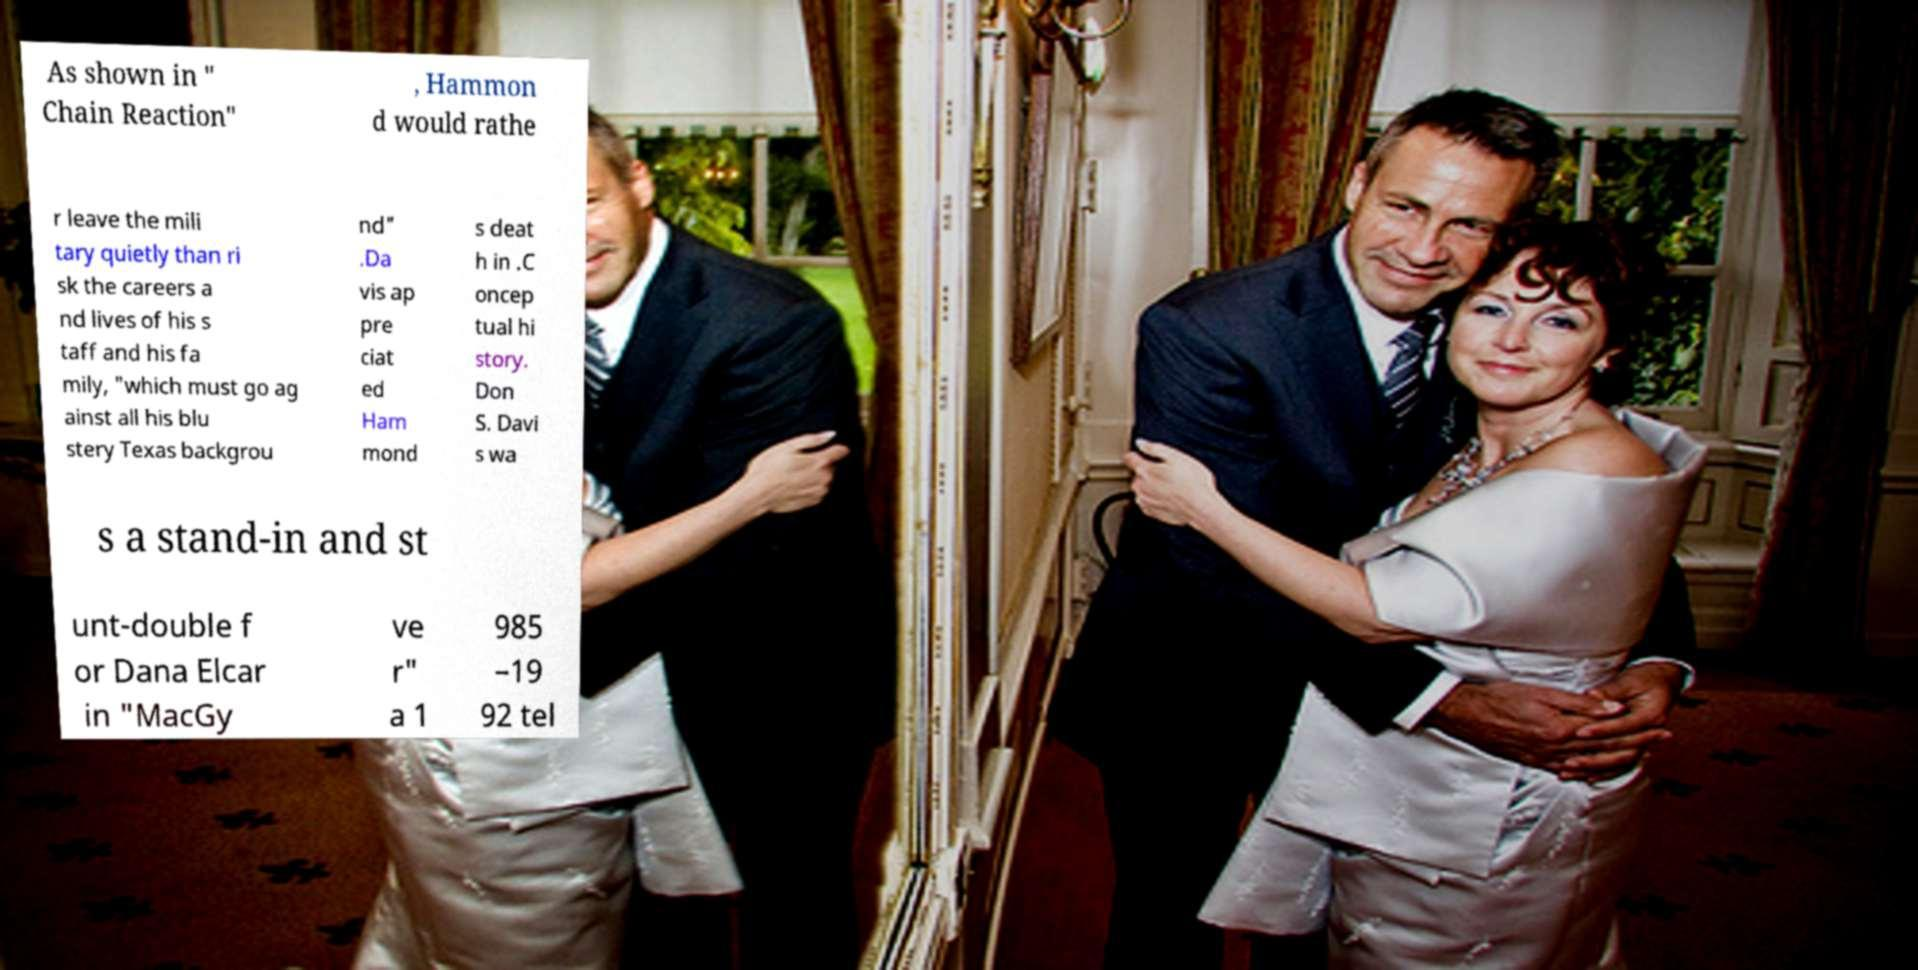Can you read and provide the text displayed in the image?This photo seems to have some interesting text. Can you extract and type it out for me? As shown in " Chain Reaction" , Hammon d would rathe r leave the mili tary quietly than ri sk the careers a nd lives of his s taff and his fa mily, "which must go ag ainst all his blu stery Texas backgrou nd" .Da vis ap pre ciat ed Ham mond s deat h in .C oncep tual hi story. Don S. Davi s wa s a stand-in and st unt-double f or Dana Elcar in "MacGy ve r" a 1 985 –19 92 tel 